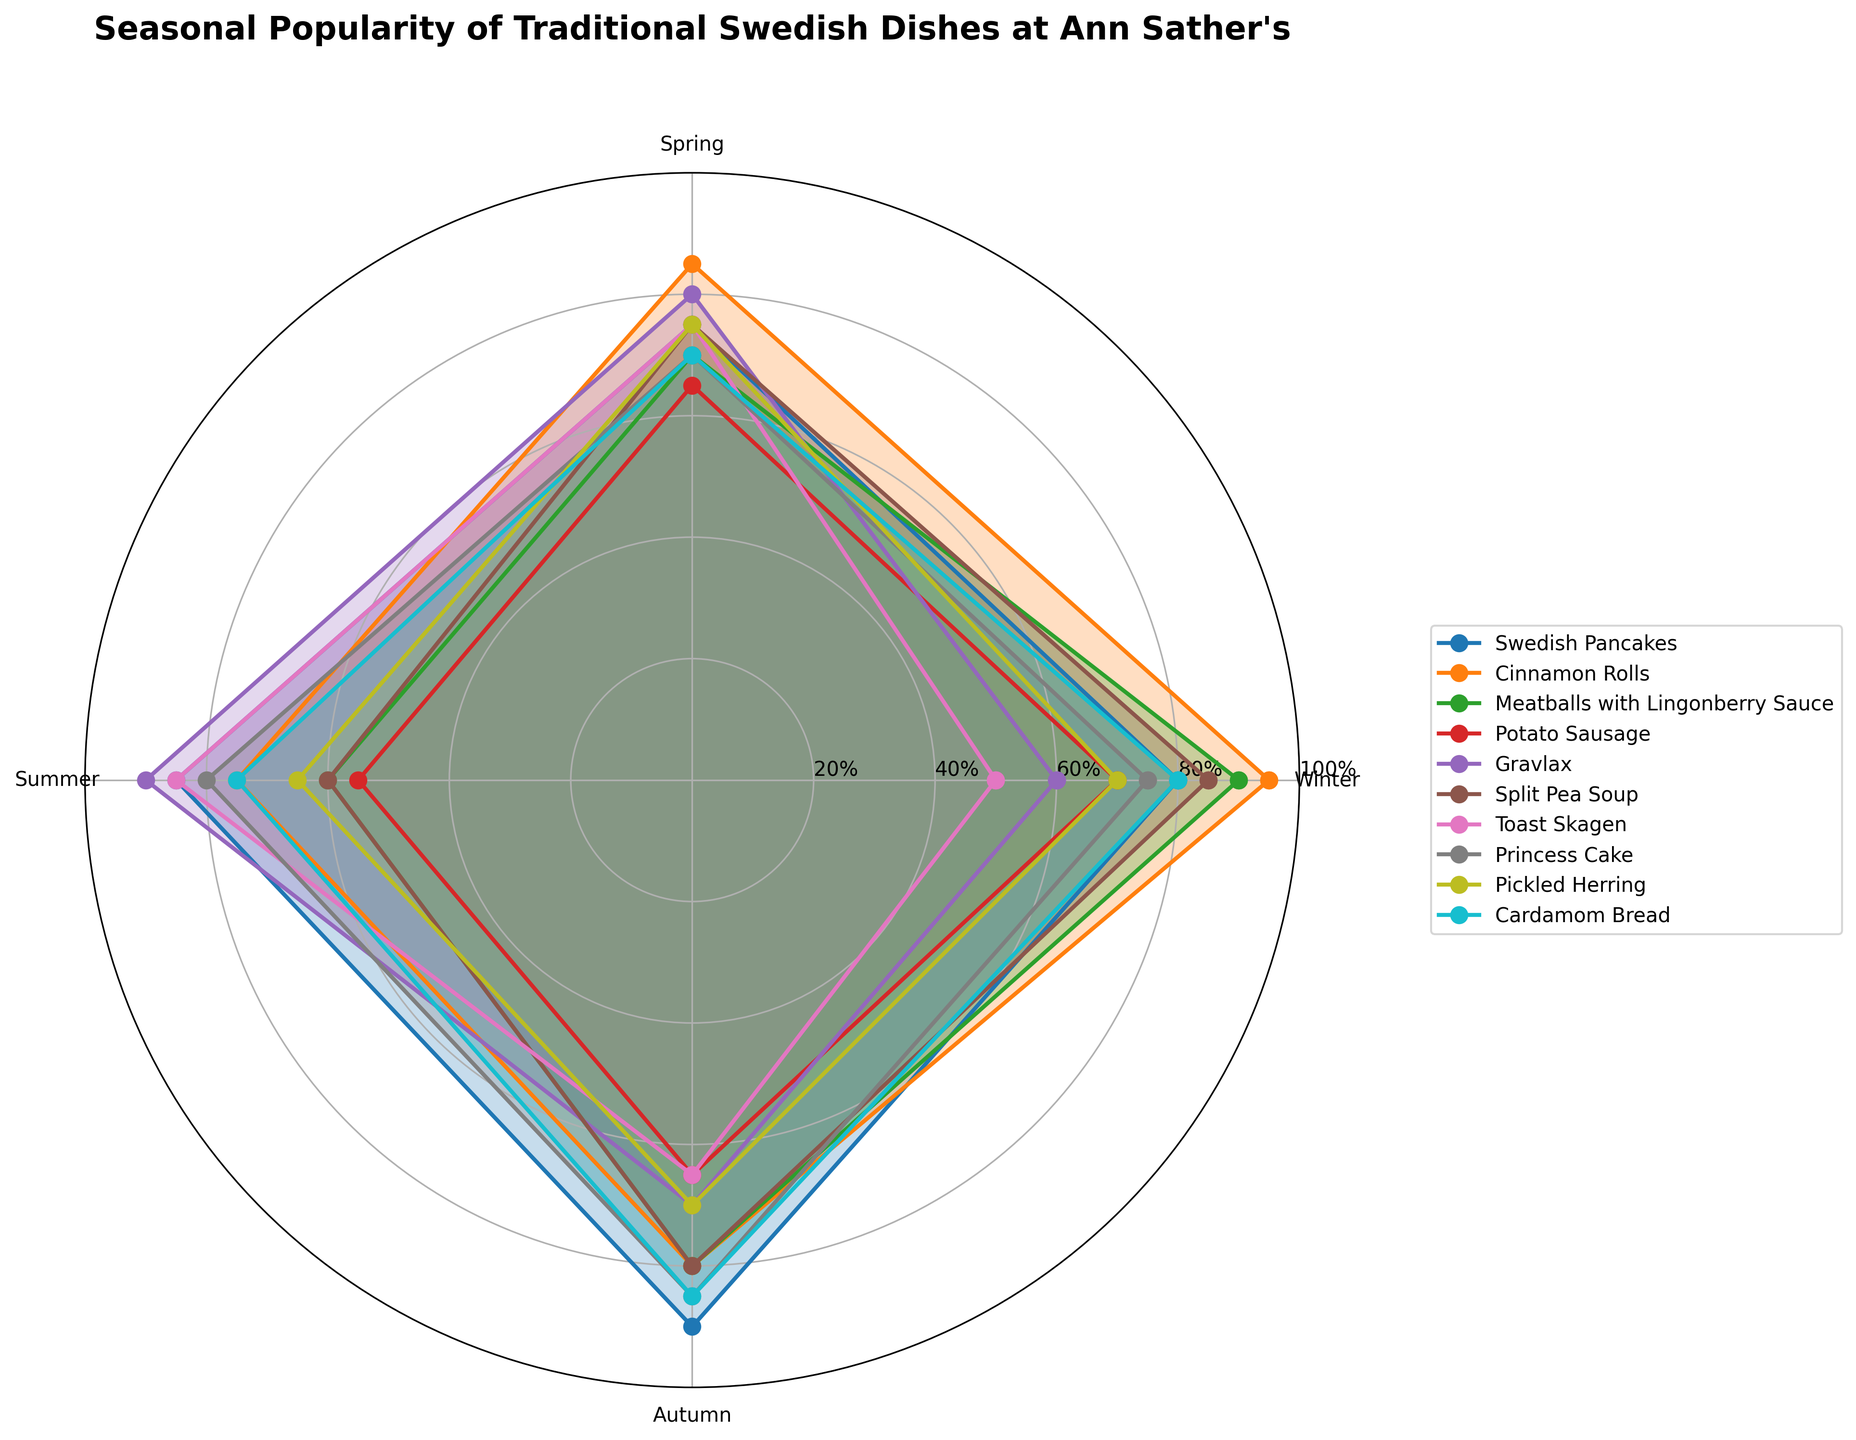Which dish is the most popular in winter? The most popular dish in winter is indicated by the length of the corresponding segment in the winter slice. The longest segment for winter corresponds to Cinnamon Rolls.
Answer: Cinnamon Rolls Which season has the highest popularity for Gravlax? Identify the longest segment for Gravlax among the four season slices. Gravlax's longest segment is in the summer slice.
Answer: Summer Compare the popularity of Swedish Pancakes and Meatballs with Lingonberry Sauce in autumn. Which is more popular? Examine the length of the segments for Swedish Pancakes and Meatballs with Lingonberry Sauce in the autumn slice. Swedish Pancakes has a longer segment than Meatballs with Lingonberry Sauce.
Answer: Swedish Pancakes What is the seasonal trend of Split Pea Soup? Observe the segments for Split Pea Soup across all four seasons (Winter, Spring, Summer, Autumn). Split Pea Soup starts high in Winter, decreases in Spring, reaches the lowest in Summer, then increases again in Autumn.
Answer: High in Winter and Autumn, Low in Summer How does the popularity of Cardamom Bread vary across the seasons? Check the lengths of the segments for Cardamom Bread in each season. Cardamom Bread is moderately popular in Winter, Spring, and Summer, and reaches peak popularity in Autumn.
Answer: Most popular in Autumn What is the difference in popularity between Cinnamon Rolls and Potato Sausage in summer? Calculate the value from the length of the segments for Cinnamon Rolls and Potato Sausage in the summer slice. Cinnamon Rolls have a value of 75% and Potato Sausage has a value of 55%. The difference is 75 - 55.
Answer: 20% Average the popularity of Pickled Herring across all seasons. Add the popularity values of Pickled Herring for each season (70, 75, 65, 70) and divide by the number of seasons, which is 4. (70 + 75 + 65 + 70) / 4 = 280 / 4.
Answer: 70% Which two dishes have similar popularity trends across the seasons, and what are those trends? Look for two sets of segments that have similar lengths in corresponding seasons. Swedish Pancakes and Princess Cake have similar trends: moderately high in Spring, peak in Autumn.
Answer: Swedish Pancakes, Princess Cake 